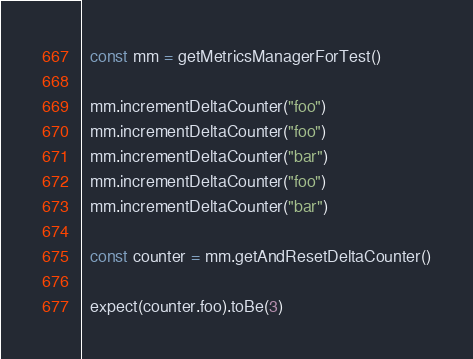Convert code to text. <code><loc_0><loc_0><loc_500><loc_500><_TypeScript_>  const mm = getMetricsManagerForTest()

  mm.incrementDeltaCounter("foo")
  mm.incrementDeltaCounter("foo")
  mm.incrementDeltaCounter("bar")
  mm.incrementDeltaCounter("foo")
  mm.incrementDeltaCounter("bar")

  const counter = mm.getAndResetDeltaCounter()

  expect(counter.foo).toBe(3)</code> 